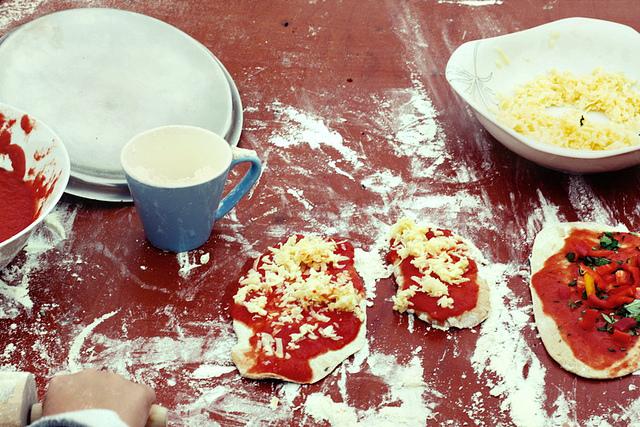What is being made on the counter?
Keep it brief. Pizza. How many cups are in the picture?
Be succinct. 1. Why is the table so messy?
Write a very short answer. Cooking. 